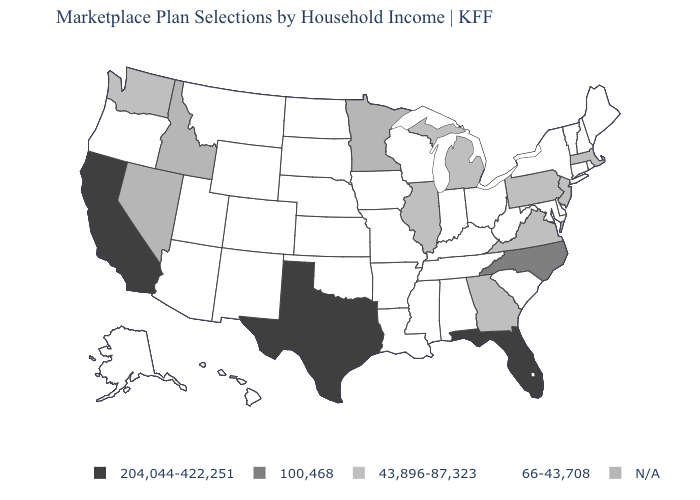What is the value of Georgia?
Concise answer only. 43,896-87,323. Name the states that have a value in the range N/A?
Keep it brief. Idaho, Minnesota, Nevada. Is the legend a continuous bar?
Answer briefly. No. Among the states that border Arizona , which have the highest value?
Concise answer only. California. Which states have the lowest value in the USA?
Answer briefly. Alabama, Alaska, Arizona, Arkansas, Colorado, Connecticut, Delaware, Hawaii, Indiana, Iowa, Kansas, Kentucky, Louisiana, Maine, Maryland, Mississippi, Missouri, Montana, Nebraska, New Hampshire, New Mexico, New York, North Dakota, Ohio, Oklahoma, Oregon, Rhode Island, South Carolina, South Dakota, Tennessee, Utah, Vermont, West Virginia, Wisconsin, Wyoming. Does Pennsylvania have the lowest value in the Northeast?
Concise answer only. No. Does Montana have the lowest value in the USA?
Answer briefly. Yes. What is the value of Missouri?
Give a very brief answer. 66-43,708. Which states have the lowest value in the South?
Write a very short answer. Alabama, Arkansas, Delaware, Kentucky, Louisiana, Maryland, Mississippi, Oklahoma, South Carolina, Tennessee, West Virginia. Does Michigan have the lowest value in the MidWest?
Quick response, please. No. Name the states that have a value in the range 66-43,708?
Be succinct. Alabama, Alaska, Arizona, Arkansas, Colorado, Connecticut, Delaware, Hawaii, Indiana, Iowa, Kansas, Kentucky, Louisiana, Maine, Maryland, Mississippi, Missouri, Montana, Nebraska, New Hampshire, New Mexico, New York, North Dakota, Ohio, Oklahoma, Oregon, Rhode Island, South Carolina, South Dakota, Tennessee, Utah, Vermont, West Virginia, Wisconsin, Wyoming. What is the value of Idaho?
Answer briefly. N/A. Is the legend a continuous bar?
Answer briefly. No. 